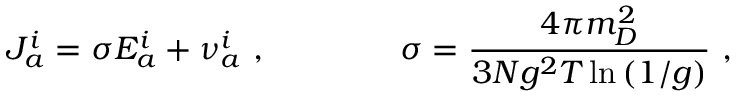Convert formula to latex. <formula><loc_0><loc_0><loc_500><loc_500>J _ { a } ^ { i } = \sigma E _ { a } ^ { i } + \nu _ { a } ^ { i } \ , \quad \sigma = \frac { 4 \pi m _ { D } ^ { 2 } } { 3 N g ^ { 2 } T \ln \left ( 1 / g \right ) } \ ,</formula> 